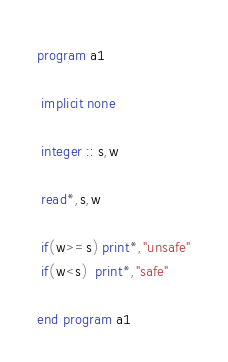<code> <loc_0><loc_0><loc_500><loc_500><_FORTRAN_>program a1

 implicit none

 integer :: s,w

 read*,s,w

 if(w>=s) print*,"unsafe"
 if(w<s)  print*,"safe"

end program a1</code> 